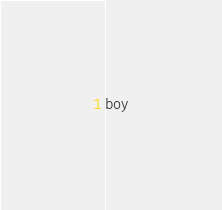<code> <loc_0><loc_0><loc_500><loc_500><_CSS_>boy

</code> 